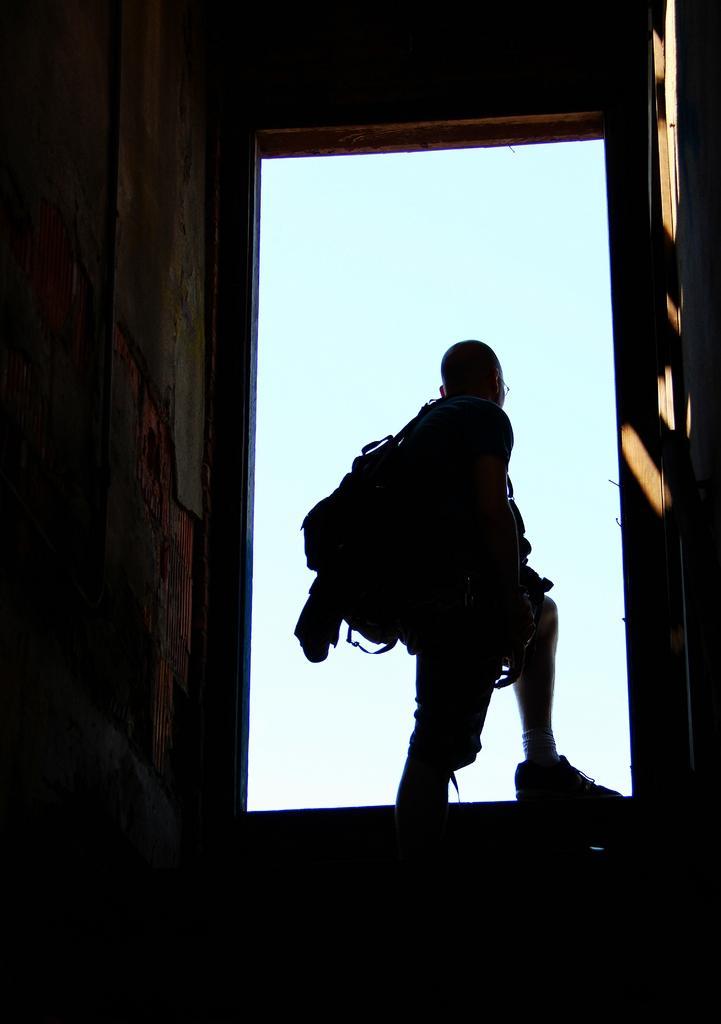Can you describe this image briefly? In this picture I can see a person standing with a backpack, and there is a wall. 